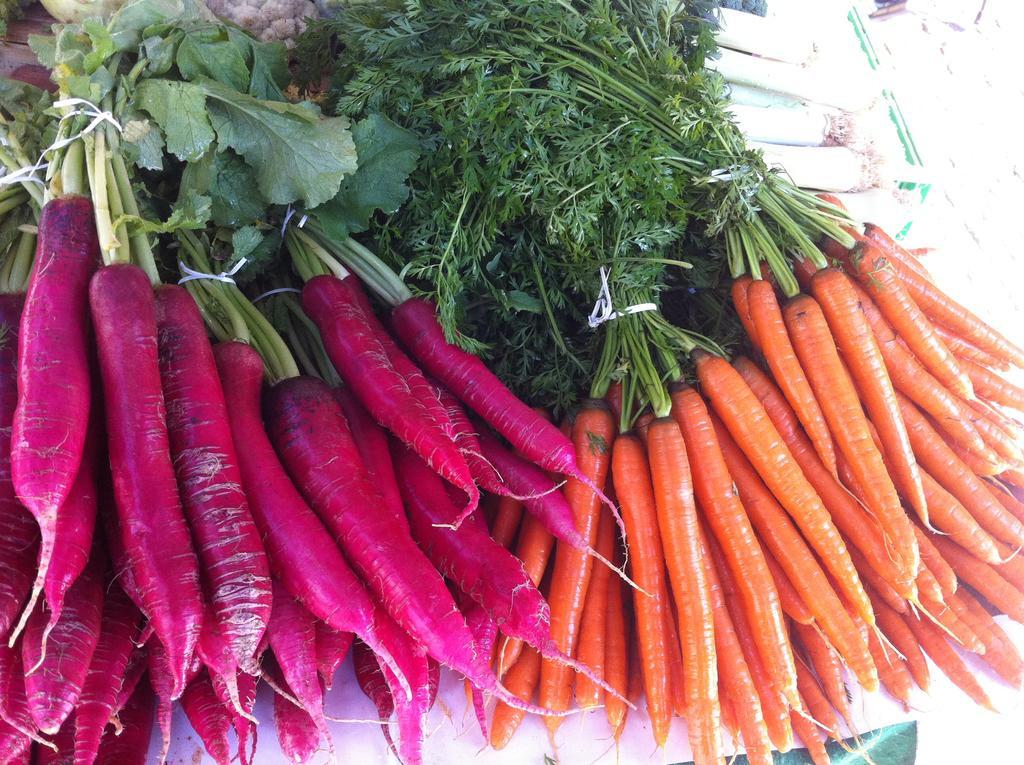Please provide a concise description of this image. In the image there are pink radishes and carrots. 